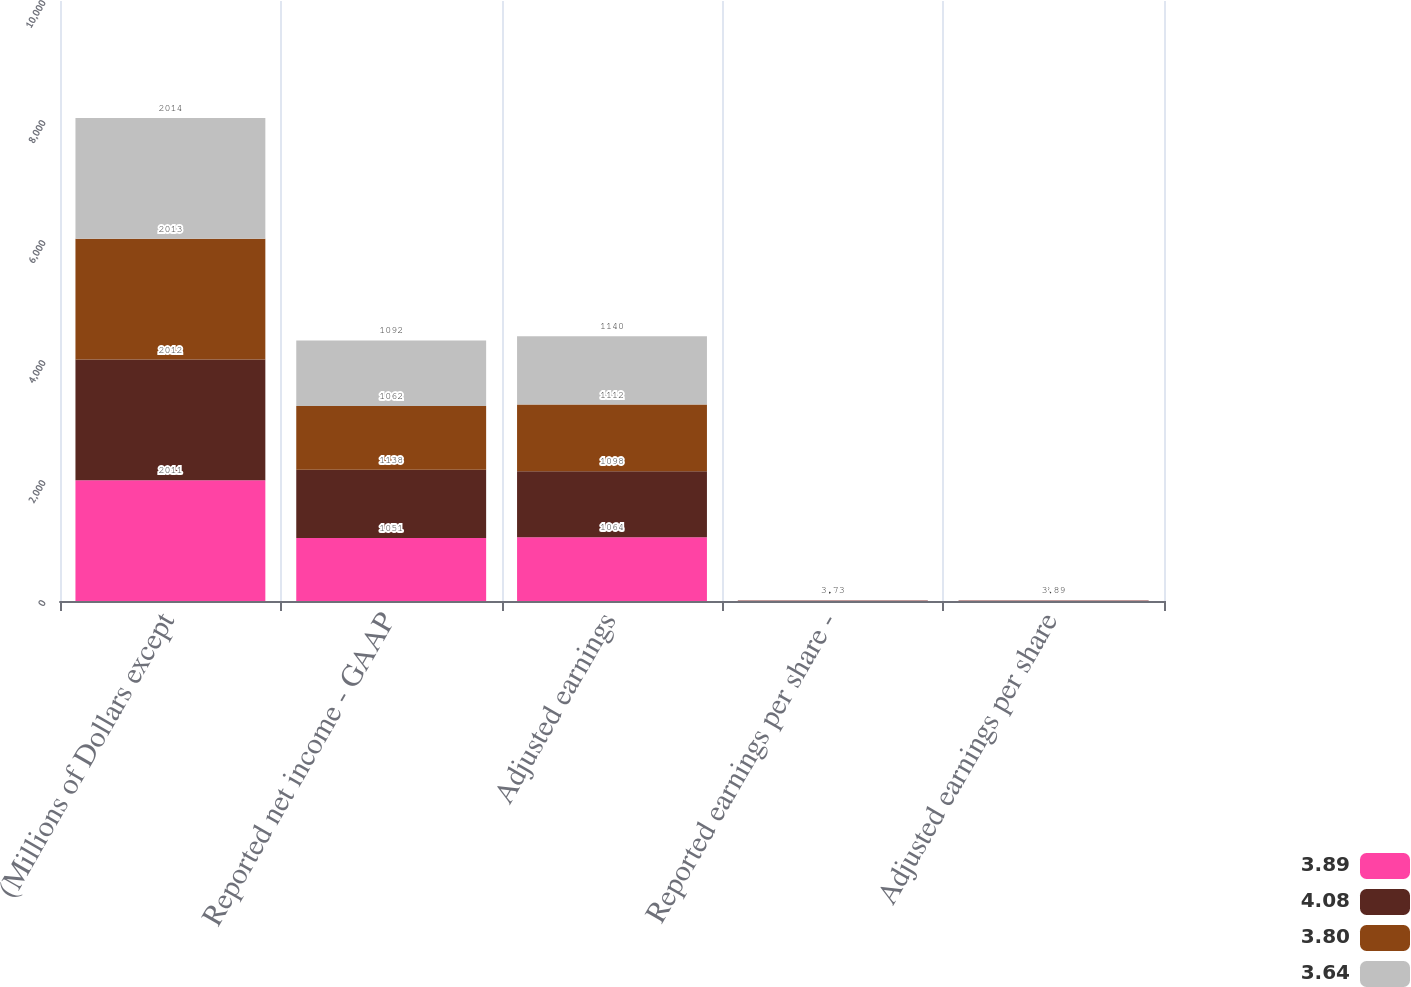<chart> <loc_0><loc_0><loc_500><loc_500><stacked_bar_chart><ecel><fcel>(Millions of Dollars except<fcel>Reported net income - GAAP<fcel>Adjusted earnings<fcel>Reported earnings per share -<fcel>Adjusted earnings per share<nl><fcel>3.89<fcel>2011<fcel>1051<fcel>1064<fcel>3.59<fcel>3.64<nl><fcel>4.08<fcel>2012<fcel>1138<fcel>1098<fcel>3.88<fcel>3.75<nl><fcel>3.8<fcel>2013<fcel>1062<fcel>1112<fcel>3.62<fcel>3.8<nl><fcel>3.64<fcel>2014<fcel>1092<fcel>1140<fcel>3.73<fcel>3.89<nl></chart> 